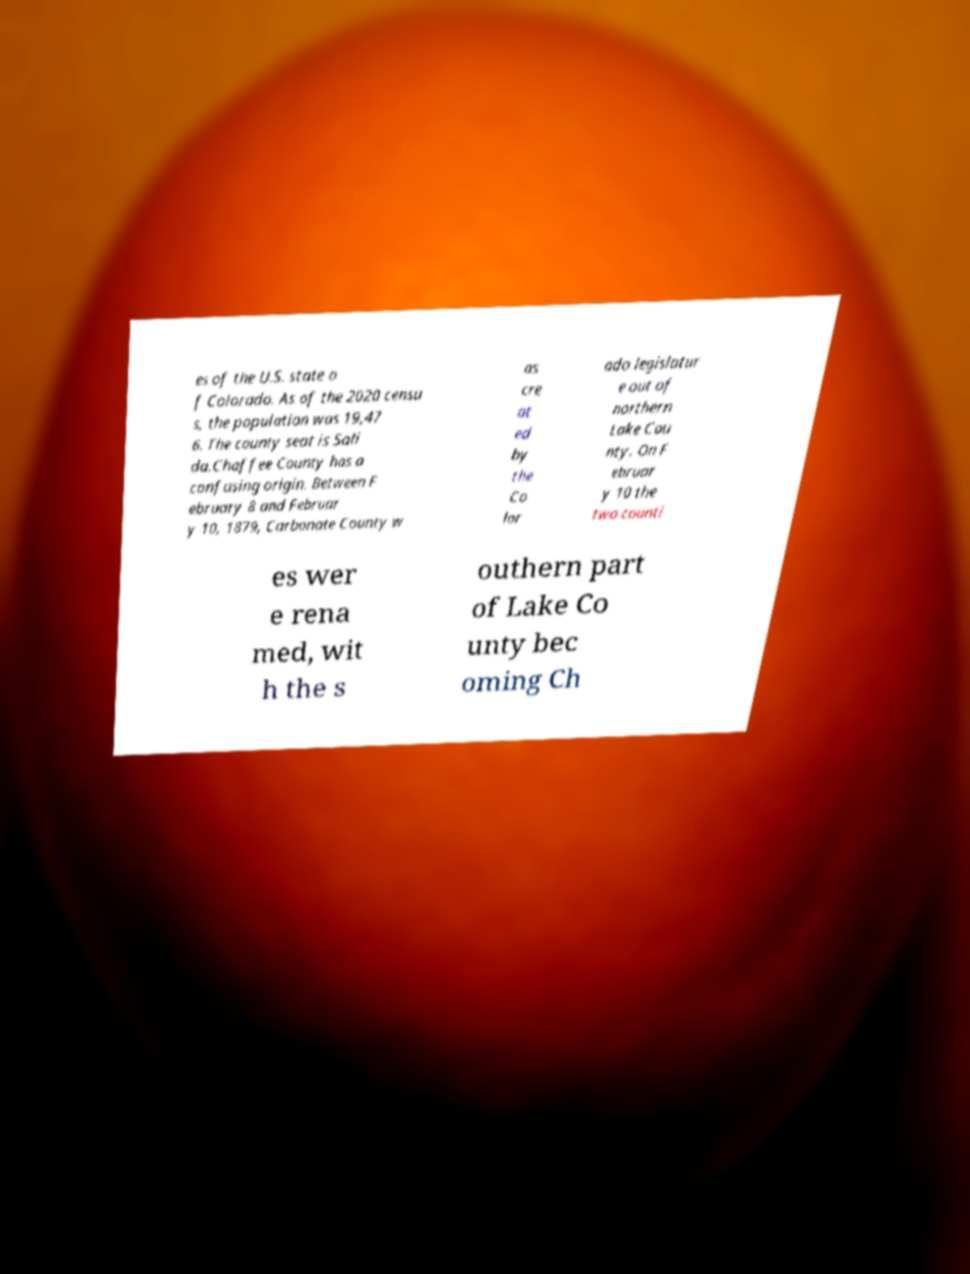Please identify and transcribe the text found in this image. es of the U.S. state o f Colorado. As of the 2020 censu s, the population was 19,47 6. The county seat is Sali da.Chaffee County has a confusing origin. Between F ebruary 8 and Februar y 10, 1879, Carbonate County w as cre at ed by the Co lor ado legislatur e out of northern Lake Cou nty. On F ebruar y 10 the two counti es wer e rena med, wit h the s outhern part of Lake Co unty bec oming Ch 